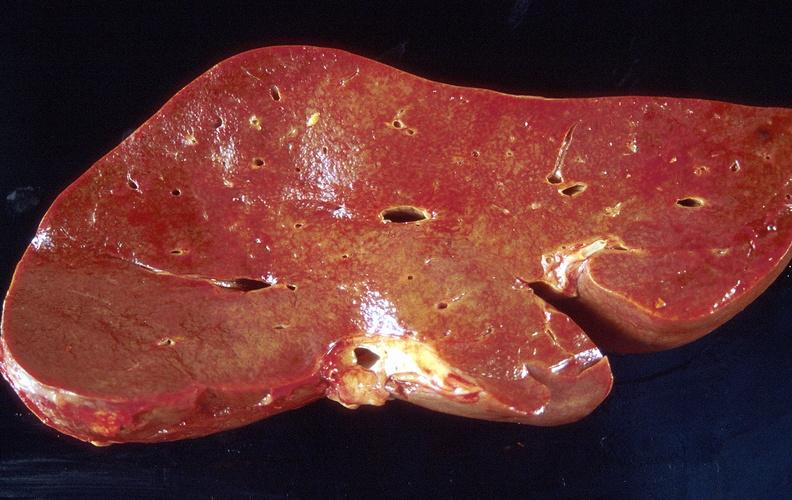what is present?
Answer the question using a single word or phrase. Hepatobiliary 